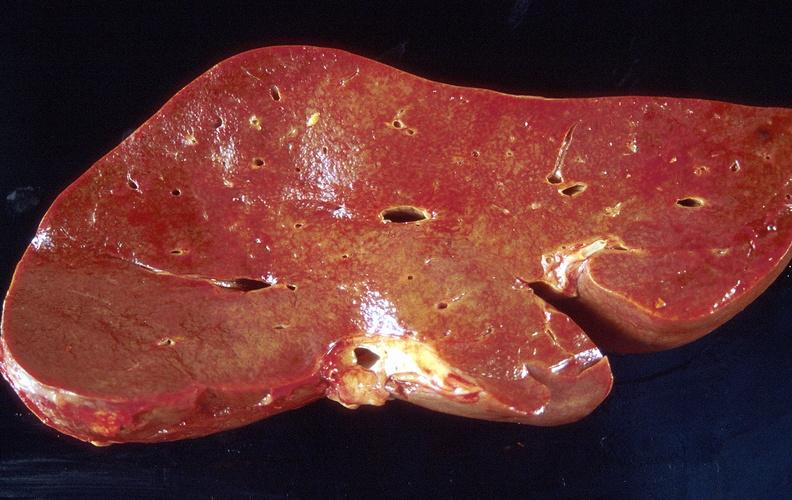what is present?
Answer the question using a single word or phrase. Hepatobiliary 